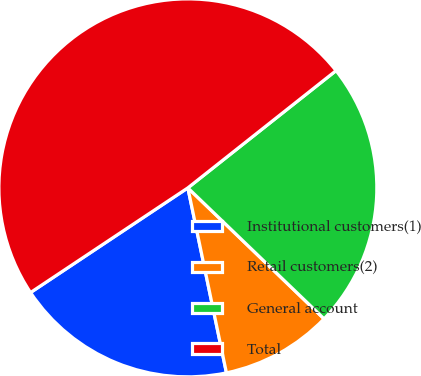Convert chart. <chart><loc_0><loc_0><loc_500><loc_500><pie_chart><fcel>Institutional customers(1)<fcel>Retail customers(2)<fcel>General account<fcel>Total<nl><fcel>18.93%<fcel>9.54%<fcel>22.84%<fcel>48.69%<nl></chart> 